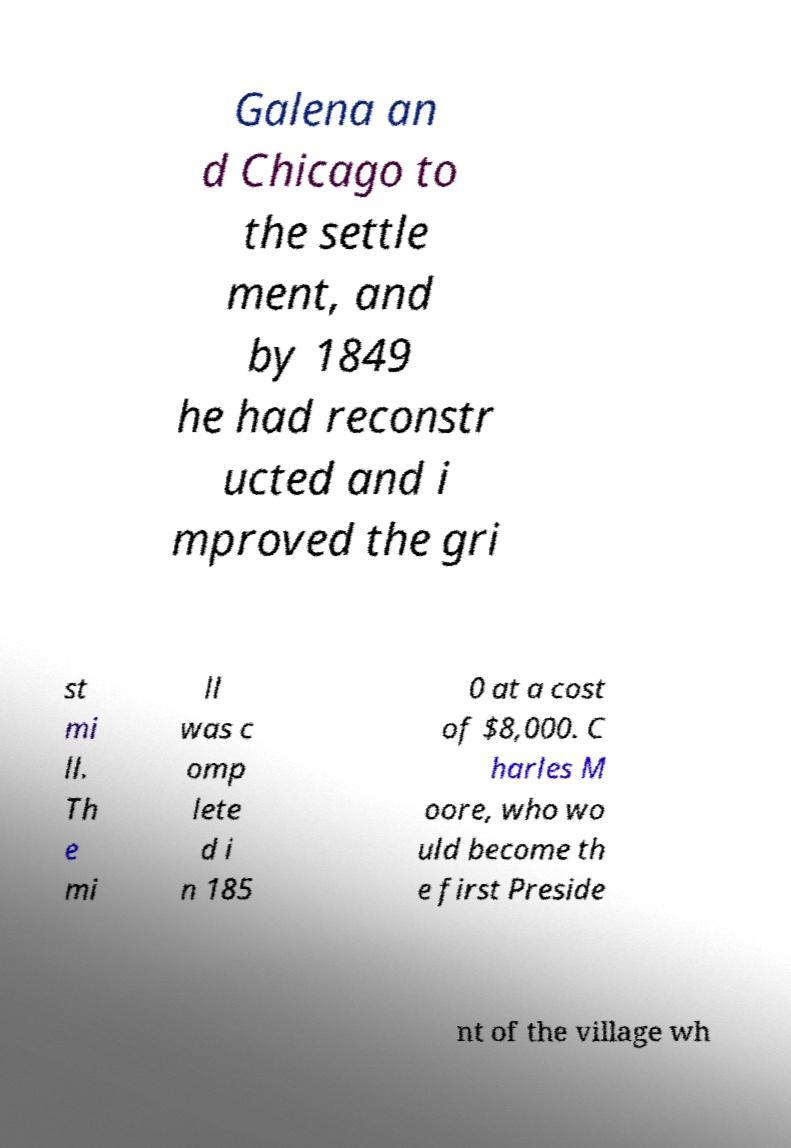Could you extract and type out the text from this image? Galena an d Chicago to the settle ment, and by 1849 he had reconstr ucted and i mproved the gri st mi ll. Th e mi ll was c omp lete d i n 185 0 at a cost of $8,000. C harles M oore, who wo uld become th e first Preside nt of the village wh 